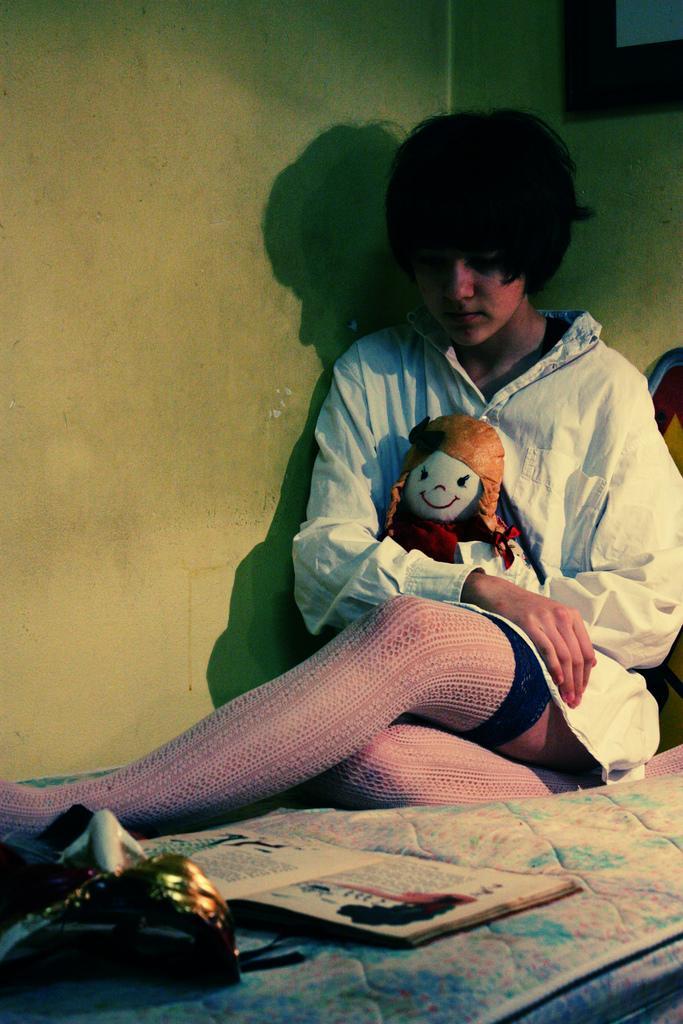Could you give a brief overview of what you see in this image? In this image we can see a person holding a toy and sitting on the surface which looks like a bed and there is a book and some other objects and we can see the wall. 